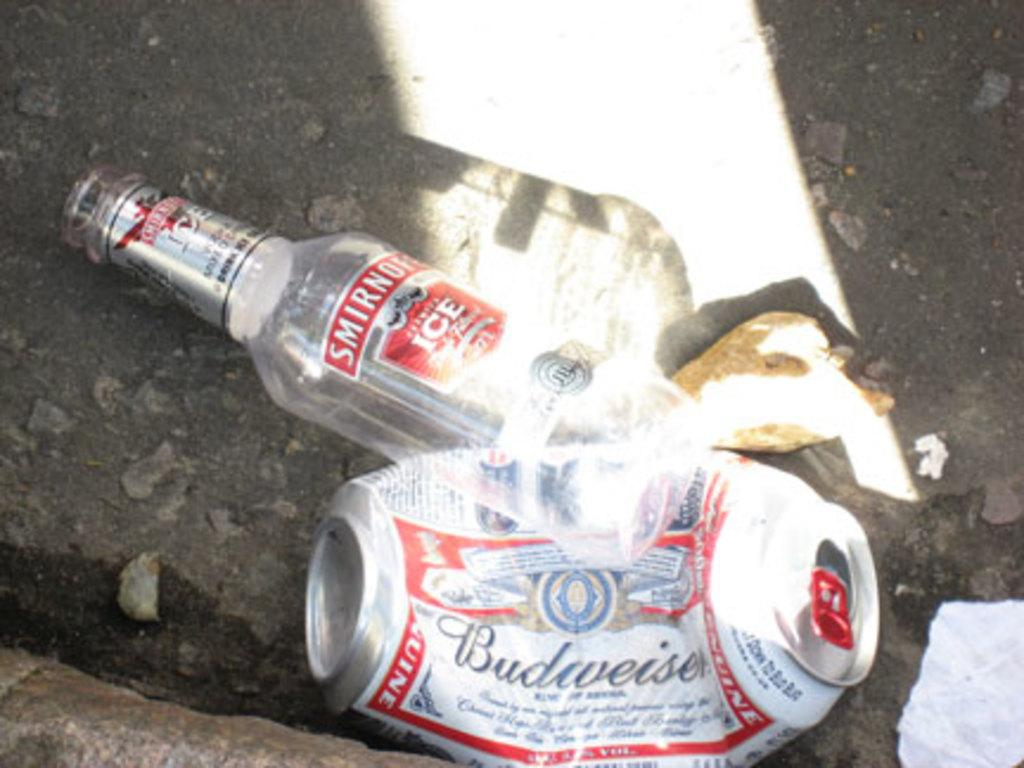<image>
Present a compact description of the photo's key features. A smirnoff bottle and crushed up budweiser can on the ground. 